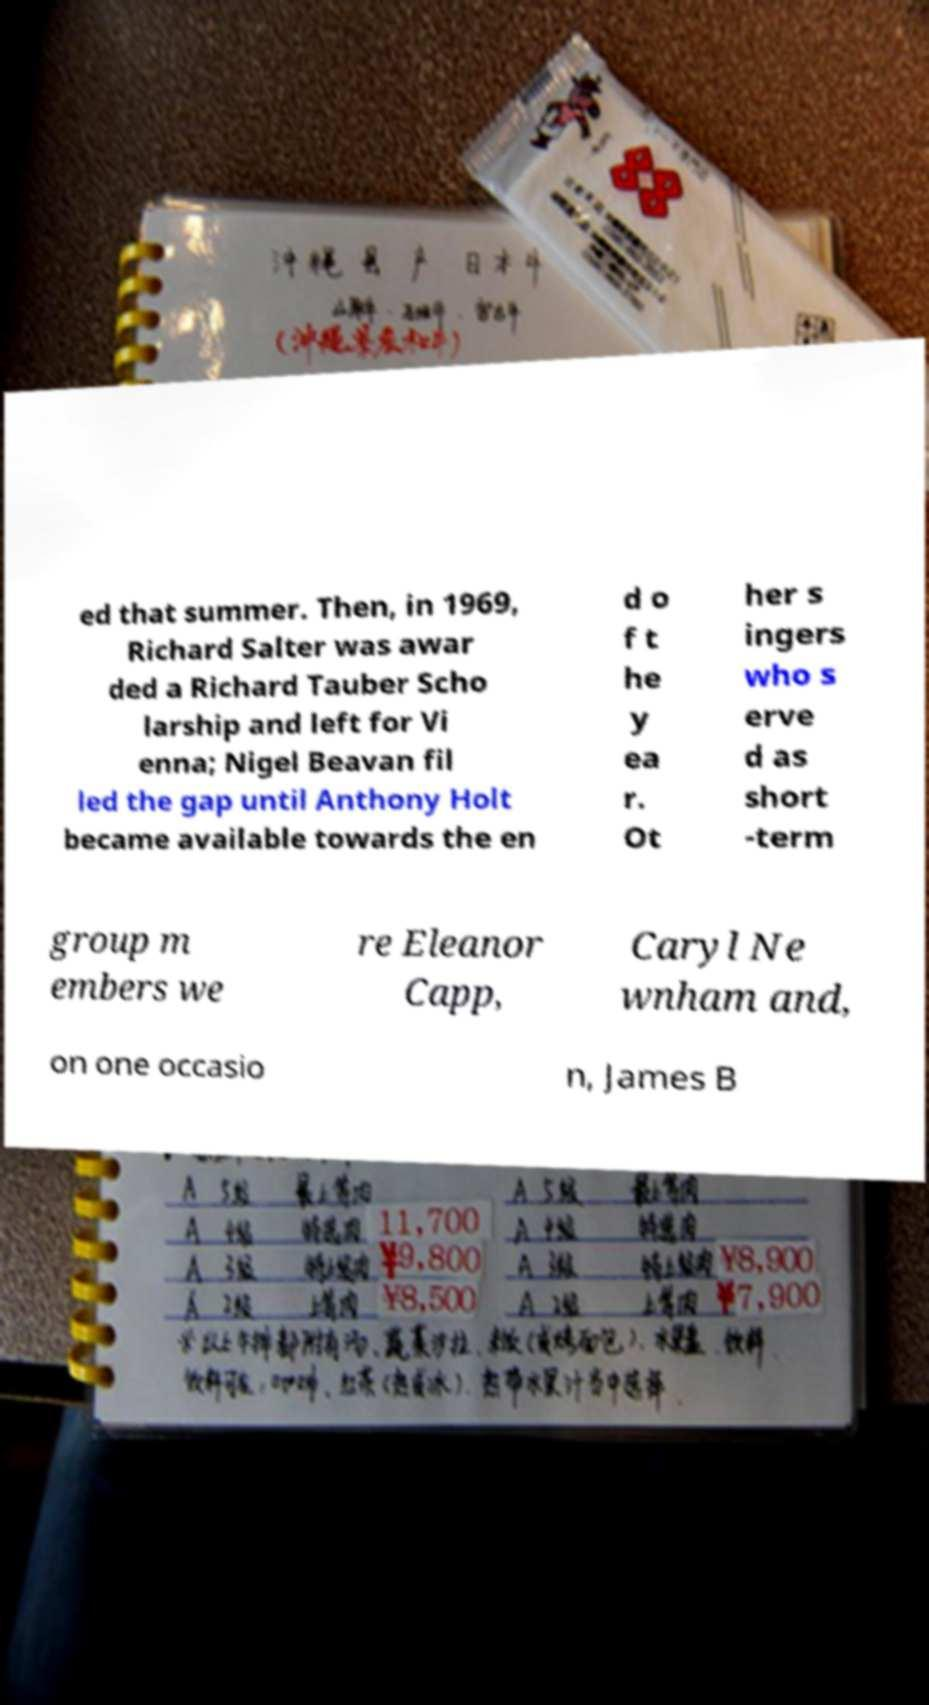What messages or text are displayed in this image? I need them in a readable, typed format. ed that summer. Then, in 1969, Richard Salter was awar ded a Richard Tauber Scho larship and left for Vi enna; Nigel Beavan fil led the gap until Anthony Holt became available towards the en d o f t he y ea r. Ot her s ingers who s erve d as short -term group m embers we re Eleanor Capp, Caryl Ne wnham and, on one occasio n, James B 